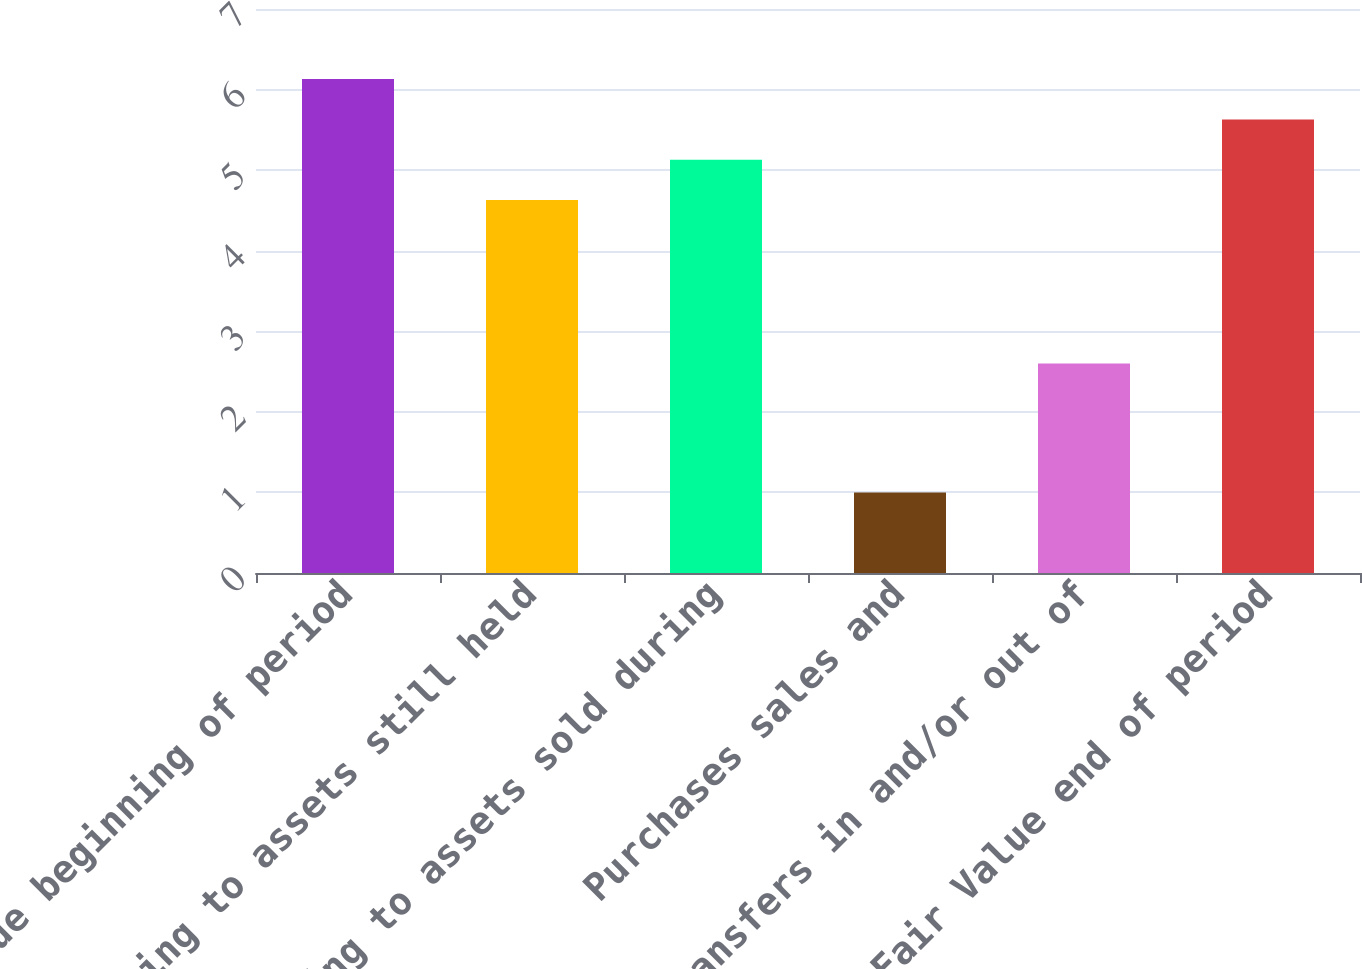Convert chart to OTSL. <chart><loc_0><loc_0><loc_500><loc_500><bar_chart><fcel>Fair Value beginning of period<fcel>Relating to assets still held<fcel>Relating to assets sold during<fcel>Purchases sales and<fcel>Transfers in and/or out of<fcel>Fair Value end of period<nl><fcel>6.13<fcel>4.63<fcel>5.13<fcel>1<fcel>2.6<fcel>5.63<nl></chart> 